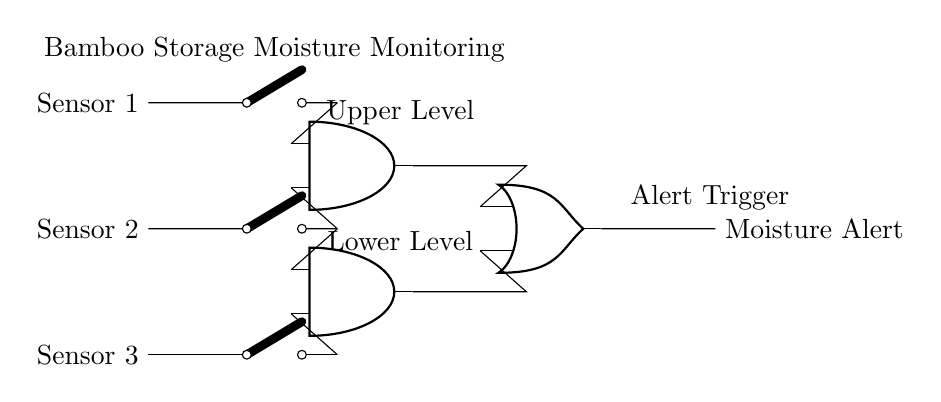What are the main components of this circuit? The main components include three sensors, two AND gates, one OR gate, and an alert output. Each element plays a critical role in monitoring the moisture levels.
Answer: sensors, AND gates, OR gate, alert output How many sensors are used in this circuit? There are three sensors connected to the circuit that detect moisture levels in the bamboo storage. This information is crucial for the overall monitoring system.
Answer: three What does the output of the OR gate represent? The output of the OR gate signifies a moisture alert, indicating whether the conditions from the inputs require attention regarding moisture levels. This combines the signals from the AND gates, which reflect sensor readings.
Answer: Moisture Alert How many inputs does each AND gate have? Each AND gate has two inputs. The design ensures that moisture is only flagged if specific sensor conditions are met.
Answer: two What condition triggers the Moisture Alert? The Moisture Alert is triggered if either of the AND gates receives a high signal from their respective sensors, indicating concerning moisture levels. This functionality is designed to provide timely alerts.
Answer: One or both AND gates active What logic does the circuit implement overall? The circuit implements a combination of AND and OR logic gates to determine if the moisture condition is critical based on the input from the sensors. It ensures alerts are only sent under defined conditions.
Answer: AND-OR logic What are the levels monitored by the AND gates? The AND gates monitor upper and lower moisture levels to help distinguish between varying degrees of moisture surrounding the bamboo, ensuring precise monitoring.
Answer: Upper Level, Lower Level 